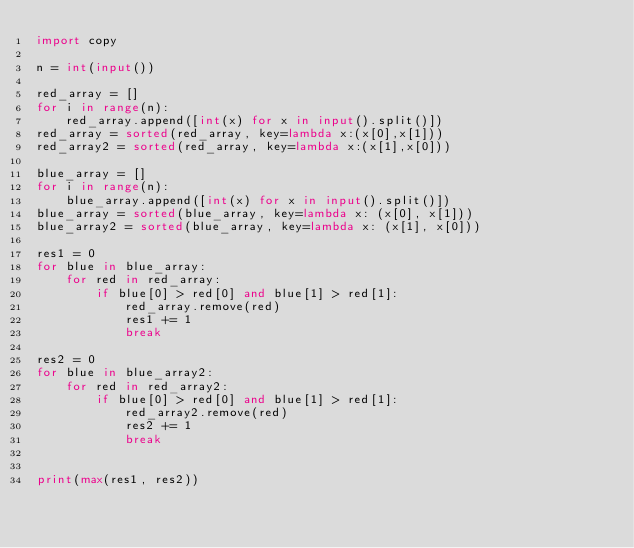Convert code to text. <code><loc_0><loc_0><loc_500><loc_500><_Python_>import copy

n = int(input())

red_array = []
for i in range(n):
    red_array.append([int(x) for x in input().split()])
red_array = sorted(red_array, key=lambda x:(x[0],x[1]))
red_array2 = sorted(red_array, key=lambda x:(x[1],x[0]))

blue_array = []
for i in range(n):
    blue_array.append([int(x) for x in input().split()])
blue_array = sorted(blue_array, key=lambda x: (x[0], x[1]))
blue_array2 = sorted(blue_array, key=lambda x: (x[1], x[0]))

res1 = 0
for blue in blue_array:
    for red in red_array:
        if blue[0] > red[0] and blue[1] > red[1]:
            red_array.remove(red)
            res1 += 1
            break

res2 = 0
for blue in blue_array2:
    for red in red_array2:
        if blue[0] > red[0] and blue[1] > red[1]:
            red_array2.remove(red)
            res2 += 1
            break


print(max(res1, res2))</code> 